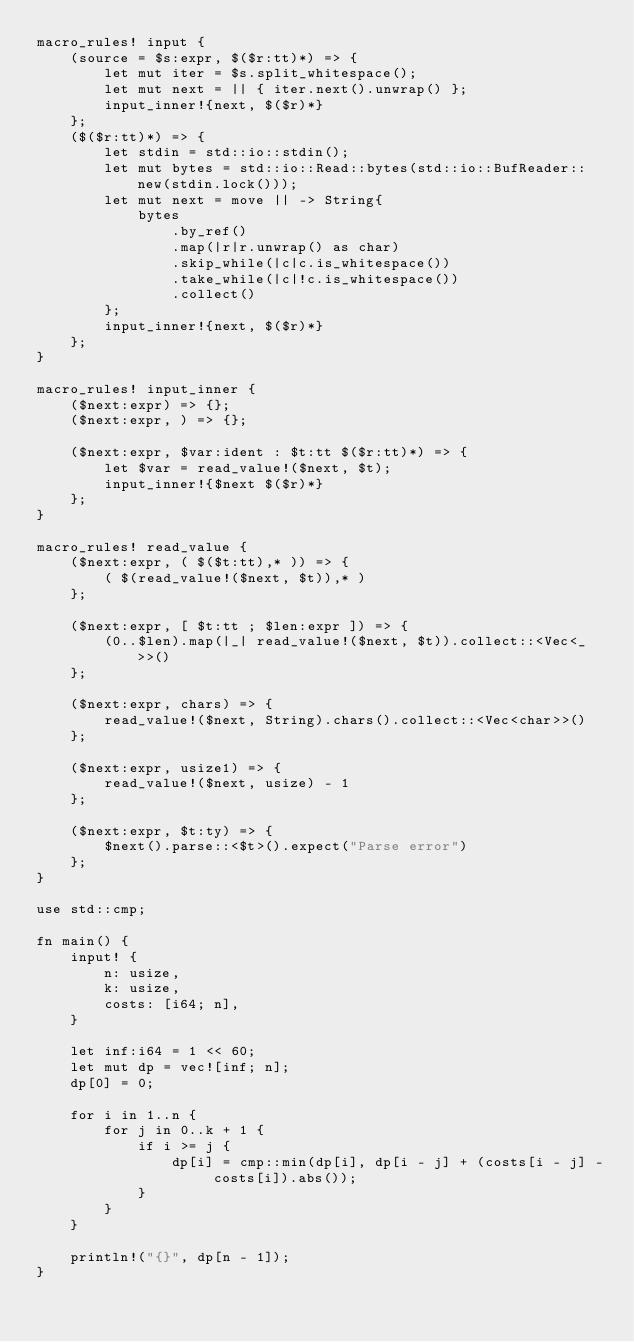<code> <loc_0><loc_0><loc_500><loc_500><_Rust_>macro_rules! input {
    (source = $s:expr, $($r:tt)*) => {
        let mut iter = $s.split_whitespace();
        let mut next = || { iter.next().unwrap() };
        input_inner!{next, $($r)*}
    };
    ($($r:tt)*) => {
        let stdin = std::io::stdin();
        let mut bytes = std::io::Read::bytes(std::io::BufReader::new(stdin.lock()));
        let mut next = move || -> String{
            bytes
                .by_ref()
                .map(|r|r.unwrap() as char)
                .skip_while(|c|c.is_whitespace())
                .take_while(|c|!c.is_whitespace())
                .collect()
        };
        input_inner!{next, $($r)*}
    };
}

macro_rules! input_inner {
    ($next:expr) => {};
    ($next:expr, ) => {};

    ($next:expr, $var:ident : $t:tt $($r:tt)*) => {
        let $var = read_value!($next, $t);
        input_inner!{$next $($r)*}
    };
}

macro_rules! read_value {
    ($next:expr, ( $($t:tt),* )) => {
        ( $(read_value!($next, $t)),* )
    };

    ($next:expr, [ $t:tt ; $len:expr ]) => {
        (0..$len).map(|_| read_value!($next, $t)).collect::<Vec<_>>()
    };

    ($next:expr, chars) => {
        read_value!($next, String).chars().collect::<Vec<char>>()
    };

    ($next:expr, usize1) => {
        read_value!($next, usize) - 1
    };

    ($next:expr, $t:ty) => {
        $next().parse::<$t>().expect("Parse error")
    };
}

use std::cmp;

fn main() {
    input! {
        n: usize,
        k: usize,
        costs: [i64; n],
    }

    let inf:i64 = 1 << 60;
    let mut dp = vec![inf; n];
    dp[0] = 0;

    for i in 1..n {
        for j in 0..k + 1 {
            if i >= j {
                dp[i] = cmp::min(dp[i], dp[i - j] + (costs[i - j] - costs[i]).abs());
            }
        }
    }

    println!("{}", dp[n - 1]);
}</code> 